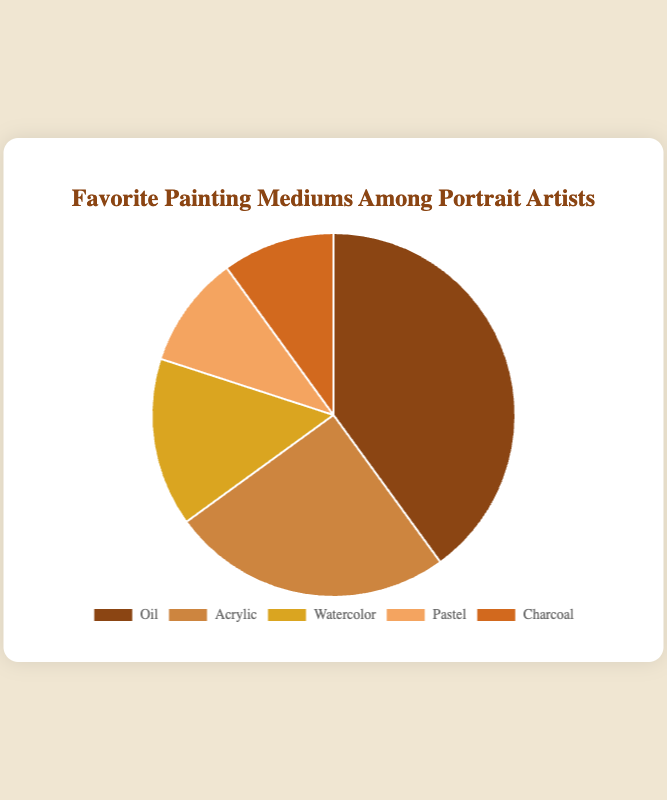Which painting medium is preferred by the largest percentage of portrait artists? The pie chart shows different segments for each painting medium, and the largest segment represents Oil, with a percentage of 40%.
Answer: Oil Which painting medium is preferred by 25% of portrait artists? By observing the segments and their corresponding labels, Acrylic is shown to be preferred by 25% of portrait artists.
Answer: Acrylic What is the total percentage for Pastel and Charcoal combined? The pie chart shows that Pastel makes up 10% and Charcoal also makes up 10%. Adding these percentages together gives us 10% + 10% = 20%.
Answer: 20% How does the popularity of Watercolor compare to Charcoal among portrait artists? Watercolor is preferred by 15% and Charcoal is preferred by 10%. Therefore, Watercolor is more popular than Charcoal by 5 percentage points.
Answer: Watercolor is more popular What percentage of portrait artists prefer either Oil or Acrylic? The pie chart segments show that Oil is preferred by 40% and Acrylic by 25%. Adding these percentages together gives us 40% + 25% = 65%.
Answer: 65% Which painting medium has the smallest following among portrait artists? The chart indicates that both Pastel and Charcoal have the smallest following, each with a share of 10%.
Answer: Pastel and Charcoal If you combine the two least preferred mediums, what is their percentage compared to the most preferred medium? The least preferred mediums, Pastel and Charcoal, each have 10%, totaling 20%. The most preferred medium, Oil, has 40%. Therefore, 20% (least preferred combined) is half of 40% (the most preferred).
Answer: 50% What is the difference in preference between Acrylic and Watercolor among portrait artists? Acrylic is preferred by 25% while Watercolor is preferred by 15%. The difference between them is 25% - 15% = 10%.
Answer: 10% If an artist does not prefer Oil, which medium are they most likely to prefer based on the chart? Excluding Oil, the next largest segment is for Acrylic, preferred by 25% of artists.
Answer: Acrylic What fraction of portrait artists prefer mediums other than Oil and Acrylic? Oil and Acrylic combined account for 40% + 25% = 65%. Therefore, mediums other than Oil and Acrylic account for 100% - 65% = 35%.
Answer: 35% 